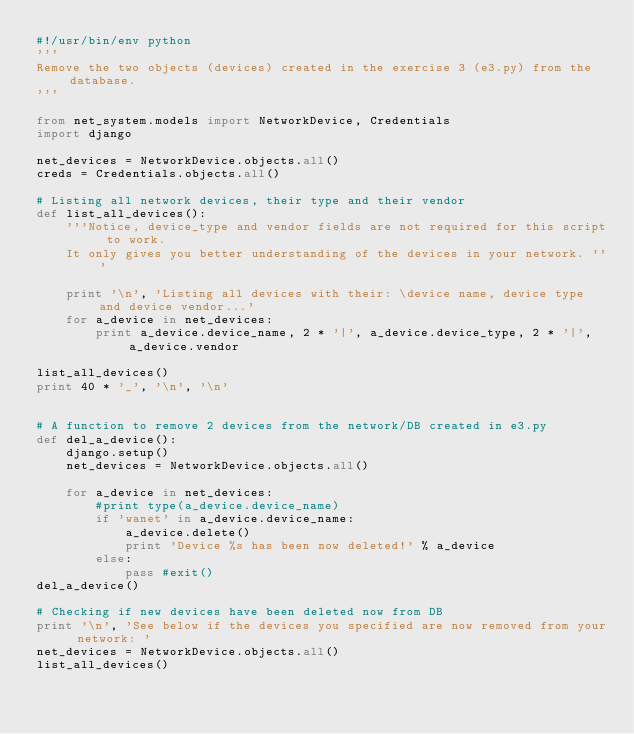<code> <loc_0><loc_0><loc_500><loc_500><_Python_>#!/usr/bin/env python
'''
Remove the two objects (devices) created in the exercise 3 (e3.py) from the database.
'''

from net_system.models import NetworkDevice, Credentials
import django

net_devices = NetworkDevice.objects.all()
creds = Credentials.objects.all()

# Listing all network devices, their type and their vendor
def list_all_devices():
    '''Notice, device_type and vendor fields are not required for this script to work.
    It only gives you better understanding of the devices in your network. '''
    
    print '\n', 'Listing all devices with their: \device name, device type and device vendor...'
    for a_device in net_devices:
        print a_device.device_name, 2 * '|', a_device.device_type, 2 * '|', a_device.vendor

list_all_devices()
print 40 * '_', '\n', '\n'


# A function to remove 2 devices from the network/DB created in e3.py
def del_a_device():
    django.setup()
    net_devices = NetworkDevice.objects.all()

    for a_device in net_devices:
        #print type(a_device.device_name)
        if 'wanet' in a_device.device_name:
            a_device.delete()
            print 'Device %s has been now deleted!' % a_device
        else:
            pass #exit()
del_a_device()

# Checking if new devices have been deleted now from DB
print '\n', 'See below if the devices you specified are now removed from your network: '
net_devices = NetworkDevice.objects.all()
list_all_devices()
</code> 